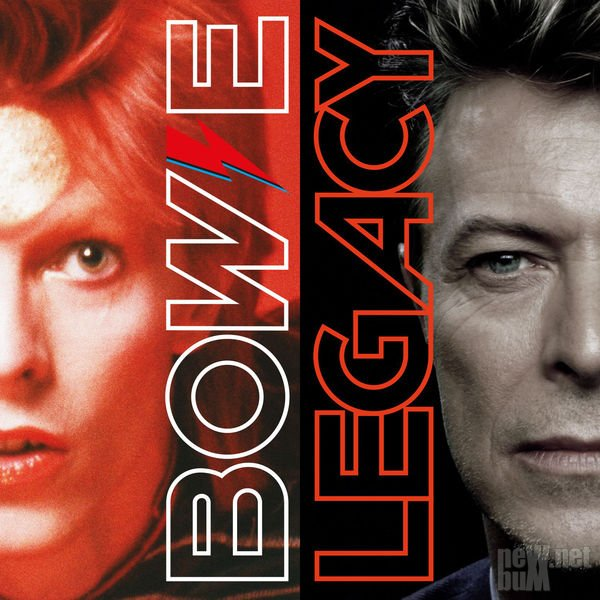What makes the lightning bolt symbol universally recognizable in pop culture? The lightning bolt symbol is universally recognizable in pop culture due to its association with powerful and dynamic entities. It represents energy, speed, and transformation, resonating strongly with themes of innovation and change. In the context of an artist, the bolt's eye-catching simplicity and striking visual contrast help cement its place as an iconic and memorable symbol. Its use by prominent figures in music and entertainment further solidifies its status as a cultural icon, bridging various eras and artistic expressions. Imagine if the lightning bolt was a portal to another universe. What kind of world would it lead to? If the lightning bolt were a portal to another universe, it would lead to a world electrified with constant energy and vibrant creativity. This realm would be a kaleidoscope of colors and sounds, where laws of physics are shaped by imagination. Buildings would pulse with neon lights, and skies might shift with waves of aurora-like illuminations. Artists and creators would find boundless inspiration, and every corner would echo with innovative music and dynamic art forms. It would be a place where time fluidly moves, allowing for endless transformations and the birth of new ideas continuously. 